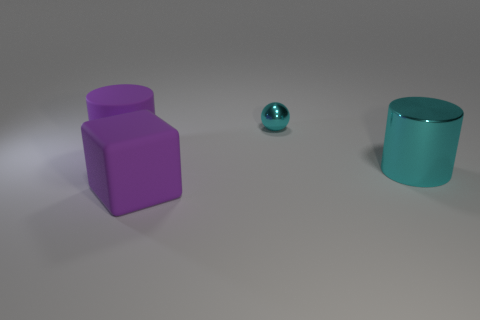Add 1 brown shiny spheres. How many objects exist? 5 Subtract all big cyan metal things. Subtract all purple cylinders. How many objects are left? 2 Add 1 big purple objects. How many big purple objects are left? 3 Add 1 large yellow metallic cylinders. How many large yellow metallic cylinders exist? 1 Subtract 0 brown blocks. How many objects are left? 4 Subtract all cubes. How many objects are left? 3 